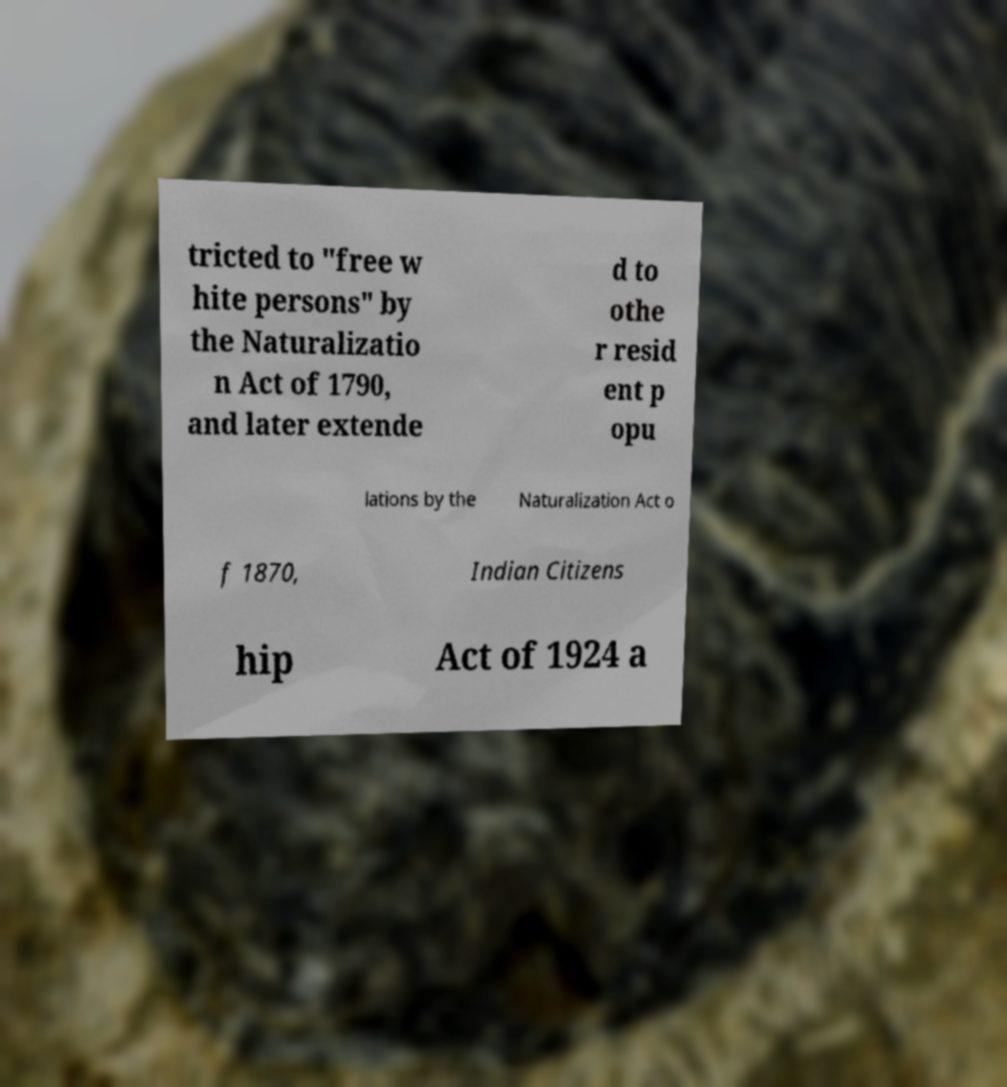For documentation purposes, I need the text within this image transcribed. Could you provide that? tricted to "free w hite persons" by the Naturalizatio n Act of 1790, and later extende d to othe r resid ent p opu lations by the Naturalization Act o f 1870, Indian Citizens hip Act of 1924 a 